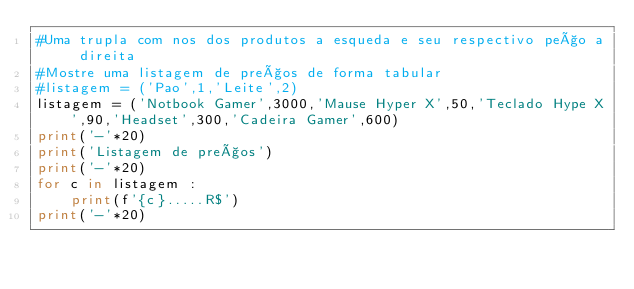<code> <loc_0><loc_0><loc_500><loc_500><_Python_>#Uma trupla com nos dos produtos a esqueda e seu respectivo peço a direita
#Mostre uma listagem de preços de forma tabular
#listagem = ('Pao',1,'Leite',2)
listagem = ('Notbook Gamer',3000,'Mause Hyper X',50,'Teclado Hype X',90,'Headset',300,'Cadeira Gamer',600)
print('-'*20)
print('Listagem de preços')
print('-'*20)
for c in listagem :
    print(f'{c}.....R$')
print('-'*20)</code> 